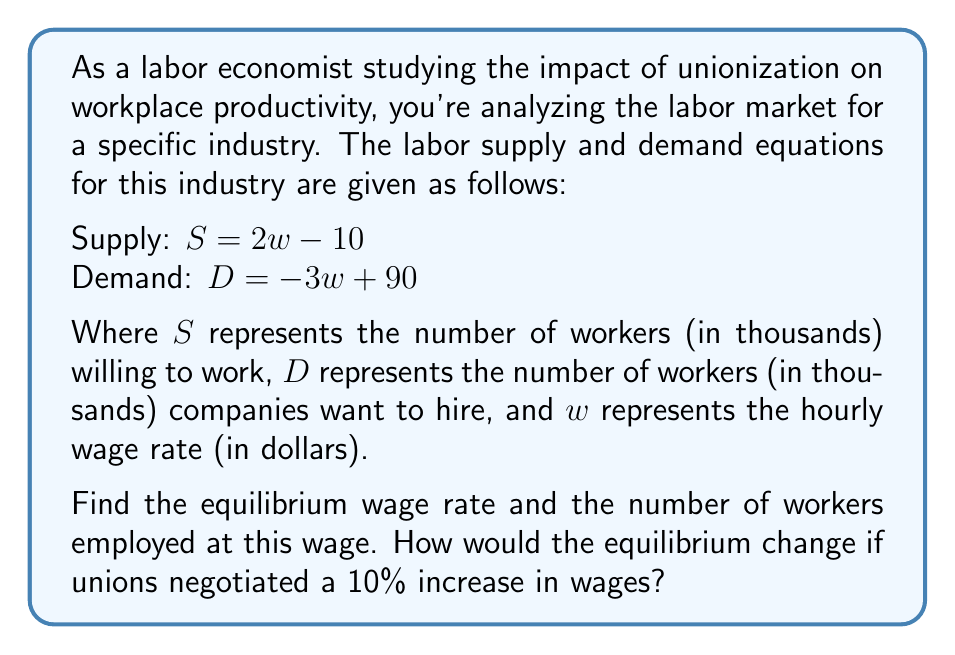Solve this math problem. To solve this problem, we'll follow these steps:

1) Find the initial equilibrium:
   At equilibrium, supply equals demand: $S = D$
   $2w - 10 = -3w + 90$
   $5w = 100$
   $w = 20$

   Substituting this wage back into either equation:
   $S = 2(20) - 10 = 30$
   $D = -3(20) + 90 = 30$

   So the equilibrium wage is $20 per hour, with 30,000 workers employed.

2) Calculate the new wage after union negotiation:
   New wage = $20 * 1.10 = $22 per hour

3) Find the new equilibrium quantities:
   At $22 per hour:
   Supply: $S = 2(22) - 10 = 34$ thousand workers
   Demand: $D = -3(22) + 90 = 24$ thousand workers

4) Analyze the change:
   The higher wage increases the supply of labor (more people want to work) but decreases the demand for labor (companies want to hire fewer workers at the higher wage).

   This creates a surplus of labor: 34,000 - 24,000 = 10,000 workers

   In reality, this surplus would put downward pressure on wages, but if the union contract fixes wages at $22, we would expect to see 24,000 workers employed (constrained by demand) and 10,000 unemployed workers.
Answer: Initial equilibrium: $20 per hour, 30,000 workers
After 10% wage increase: $22 per hour, 24,000 workers employed, 10,000 worker surplus 